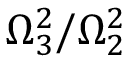<formula> <loc_0><loc_0><loc_500><loc_500>\Omega _ { 3 } ^ { 2 } / \Omega _ { 2 } ^ { 2 }</formula> 